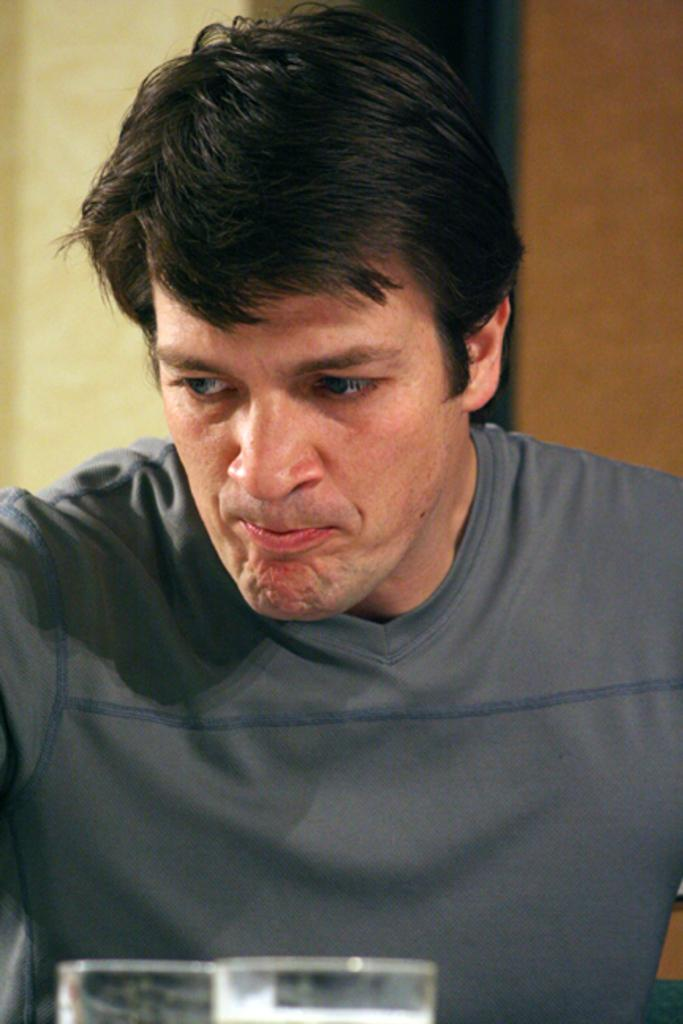Who is present in the image? There is a man in the image. What is the man wearing? The man is wearing a t-shirt. What objects are in front of the man? There are water glasses in front of the man. What can be seen behind the man? There is a wall behind the man. What type of haircut does the man have in the image? The provided facts do not mention the man's haircut, so it cannot be determined from the image. Can you see any gold objects in the image? There is no mention of gold objects in the image, so it cannot be determined from the image. 